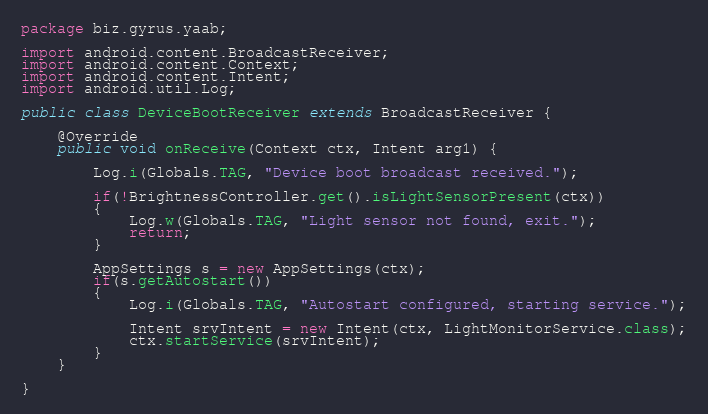Convert code to text. <code><loc_0><loc_0><loc_500><loc_500><_Java_>package biz.gyrus.yaab;

import android.content.BroadcastReceiver;
import android.content.Context;
import android.content.Intent;
import android.util.Log;

public class DeviceBootReceiver extends BroadcastReceiver {

	@Override
	public void onReceive(Context ctx, Intent arg1) {

		Log.i(Globals.TAG, "Device boot broadcast received.");
		
		if(!BrightnessController.get().isLightSensorPresent(ctx))
		{
			Log.w(Globals.TAG, "Light sensor not found, exit.");
			return;
		}
		
		AppSettings s = new AppSettings(ctx);
		if(s.getAutostart())
		{
			Log.i(Globals.TAG, "Autostart configured, starting service.");
			
			Intent srvIntent = new Intent(ctx, LightMonitorService.class);
			ctx.startService(srvIntent);
		}
	}

}
</code> 